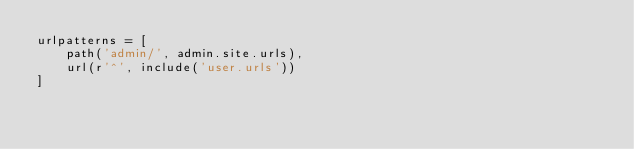<code> <loc_0><loc_0><loc_500><loc_500><_Python_>urlpatterns = [
    path('admin/', admin.site.urls),
    url(r'^', include('user.urls'))
]
</code> 